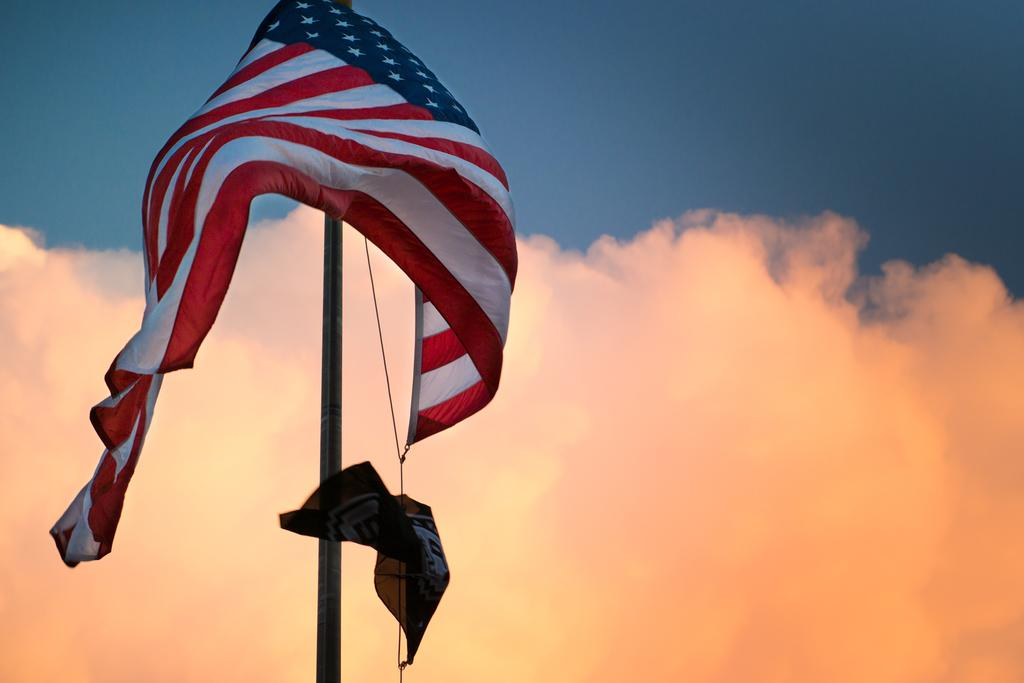What is the main object in the image? There is a flag in the image. How is the flag supported or held up? The flag is attached to a pole. Is there any additional equipment associated with the flag? Yes, there is a rope associated with the flag. What can be seen in the background of the image? There is smoke and the sky visible in the background of the image. What type of creature is causing the smoke in the image? There is no creature present in the image, and the source of the smoke is not visible or identifiable. 